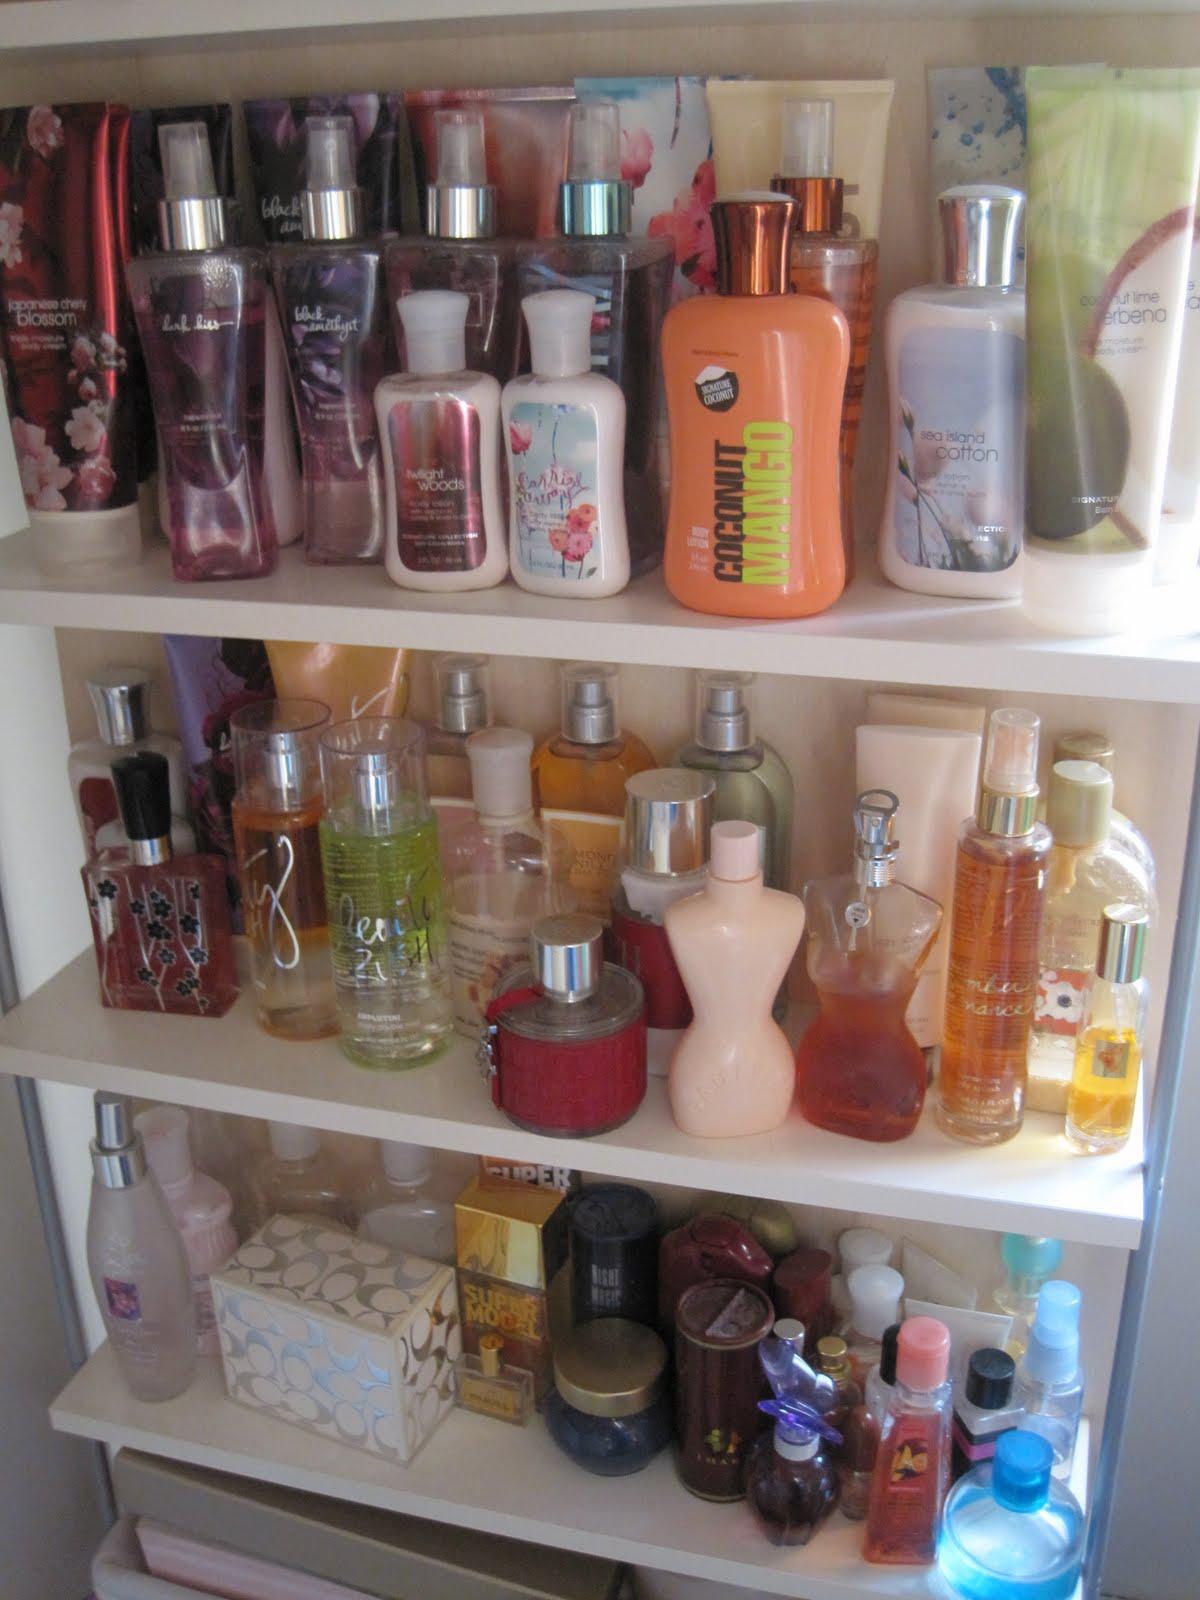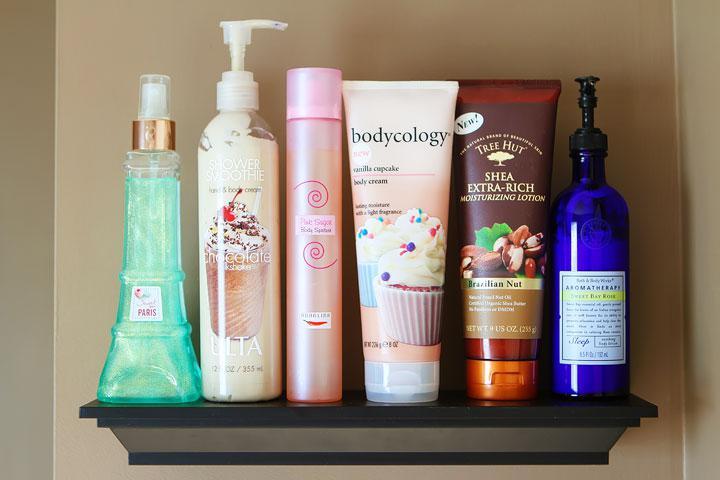The first image is the image on the left, the second image is the image on the right. Assess this claim about the two images: "An image shows one black shelf holding a row of six beauty products.". Correct or not? Answer yes or no. Yes. 